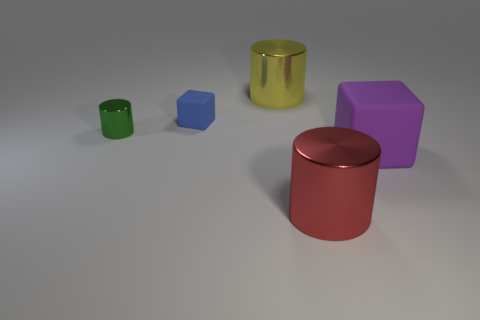Add 5 tiny yellow matte spheres. How many objects exist? 10 Subtract all cylinders. How many objects are left? 2 Subtract 0 red balls. How many objects are left? 5 Subtract all purple rubber objects. Subtract all large gray balls. How many objects are left? 4 Add 2 yellow cylinders. How many yellow cylinders are left? 3 Add 4 big green matte cubes. How many big green matte cubes exist? 4 